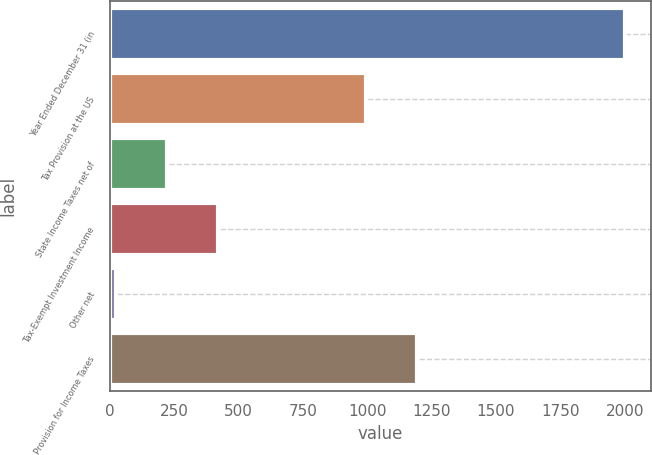<chart> <loc_0><loc_0><loc_500><loc_500><bar_chart><fcel>Year Ended December 31 (in<fcel>Tax Provision at the US<fcel>State Income Taxes net of<fcel>Tax-Exempt Investment Income<fcel>Other net<fcel>Provision for Income Taxes<nl><fcel>2003<fcel>994<fcel>220.1<fcel>418.2<fcel>22<fcel>1192.1<nl></chart> 